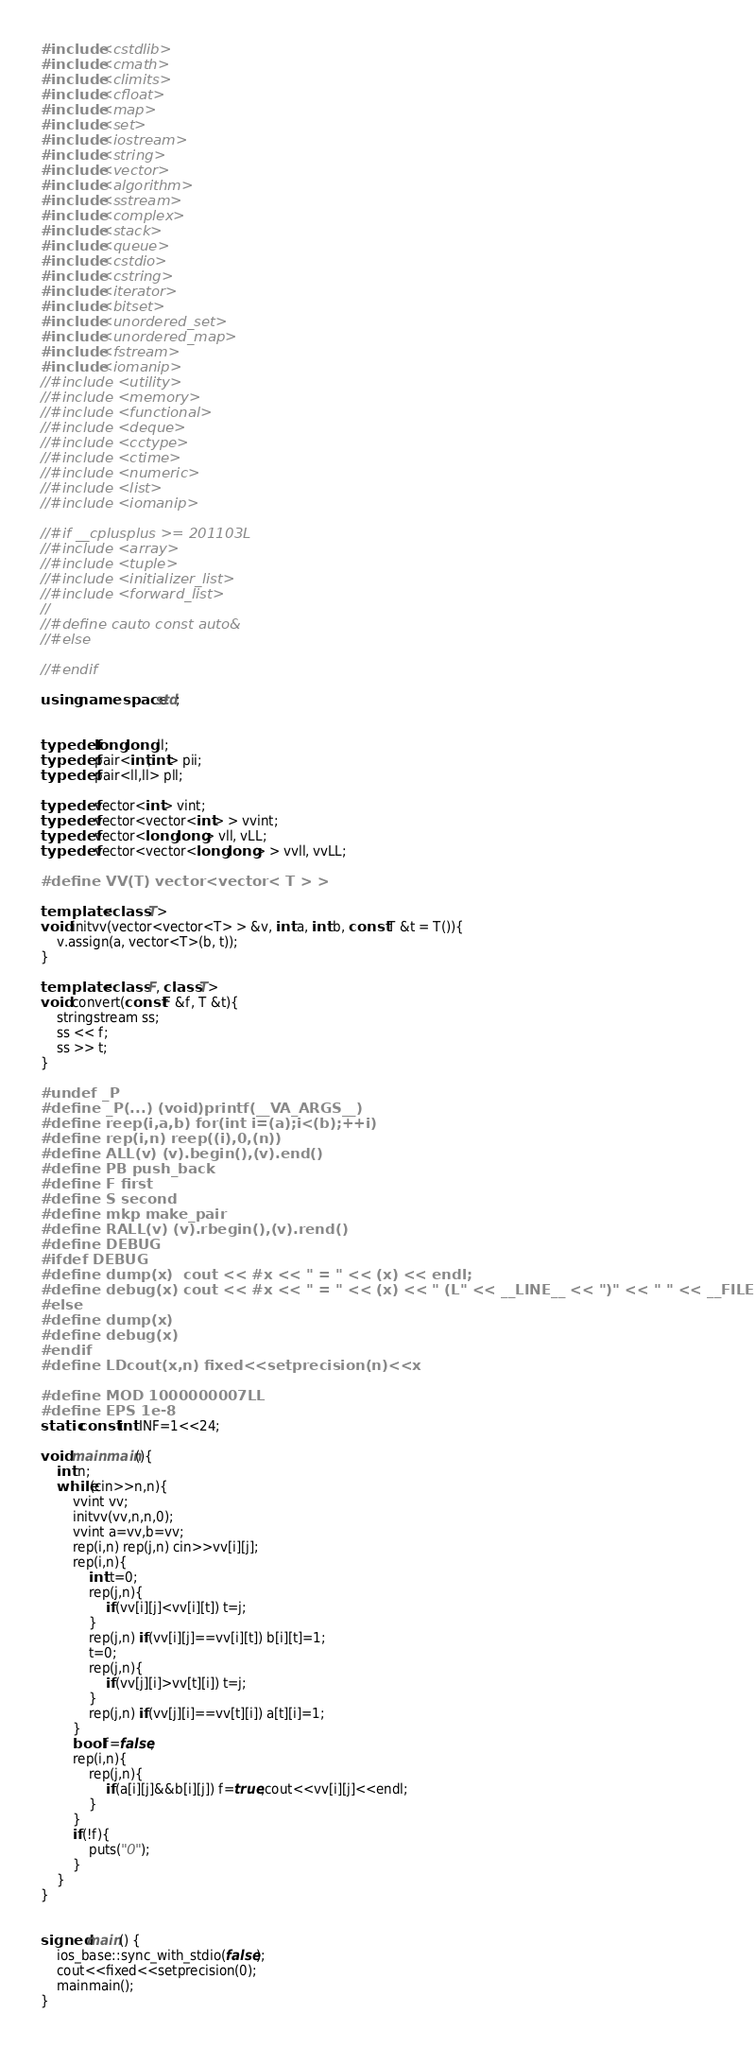<code> <loc_0><loc_0><loc_500><loc_500><_C++_>#include <cstdlib>
#include <cmath>
#include <climits>
#include <cfloat>
#include <map>
#include <set>
#include <iostream>
#include <string>
#include <vector>
#include <algorithm>
#include <sstream>
#include <complex>
#include <stack>
#include <queue>
#include <cstdio>
#include <cstring>
#include <iterator>
#include <bitset>
#include <unordered_set>
#include <unordered_map>
#include <fstream>
#include <iomanip>
//#include <utility>
//#include <memory>
//#include <functional>
//#include <deque>
//#include <cctype>
//#include <ctime>
//#include <numeric>
//#include <list>
//#include <iomanip>

//#if __cplusplus >= 201103L
//#include <array>
//#include <tuple>
//#include <initializer_list>
//#include <forward_list>
//
//#define cauto const auto&
//#else

//#endif

using namespace std;


typedef long long ll;
typedef pair<int,int> pii;
typedef pair<ll,ll> pll;

typedef vector<int> vint;
typedef vector<vector<int> > vvint;
typedef vector<long long> vll, vLL;
typedef vector<vector<long long> > vvll, vvLL;

#define VV(T) vector<vector< T > >

template <class T>
void initvv(vector<vector<T> > &v, int a, int b, const T &t = T()){
    v.assign(a, vector<T>(b, t));
}

template <class F, class T>
void convert(const F &f, T &t){
    stringstream ss;
    ss << f;
    ss >> t;
}

#undef _P
#define _P(...) (void)printf(__VA_ARGS__)
#define reep(i,a,b) for(int i=(a);i<(b);++i)
#define rep(i,n) reep((i),0,(n))
#define ALL(v) (v).begin(),(v).end()
#define PB push_back
#define F first
#define S second
#define mkp make_pair
#define RALL(v) (v).rbegin(),(v).rend()
#define DEBUG
#ifdef DEBUG
#define dump(x)  cout << #x << " = " << (x) << endl;
#define debug(x) cout << #x << " = " << (x) << " (L" << __LINE__ << ")" << " " << __FILE__ << endl;
#else
#define dump(x) 
#define debug(x) 
#endif
#define LDcout(x,n) fixed<<setprecision(n)<<x

#define MOD 1000000007LL
#define EPS 1e-8
static const int INF=1<<24;

void mainmain(){
	int n;
	while(cin>>n,n){
		vvint vv;
		initvv(vv,n,n,0);
		vvint a=vv,b=vv;
		rep(i,n) rep(j,n) cin>>vv[i][j];
		rep(i,n){
			int t=0;
			rep(j,n){
				if(vv[i][j]<vv[i][t]) t=j;
			}
			rep(j,n) if(vv[i][j]==vv[i][t]) b[i][t]=1;
			t=0;
			rep(j,n){
				if(vv[j][i]>vv[t][i]) t=j;
			}
			rep(j,n) if(vv[j][i]==vv[t][i]) a[t][i]=1;
		}
		bool f=false;
		rep(i,n){
			rep(j,n){
				if(a[i][j]&&b[i][j]) f=true,cout<<vv[i][j]<<endl;
			}
		}
		if(!f){
			puts("0");
		}
	}
}


signed main() {
	ios_base::sync_with_stdio(false);
  	cout<<fixed<<setprecision(0);
    mainmain();
}</code> 